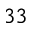Convert formula to latex. <formula><loc_0><loc_0><loc_500><loc_500>^ { 3 3 }</formula> 